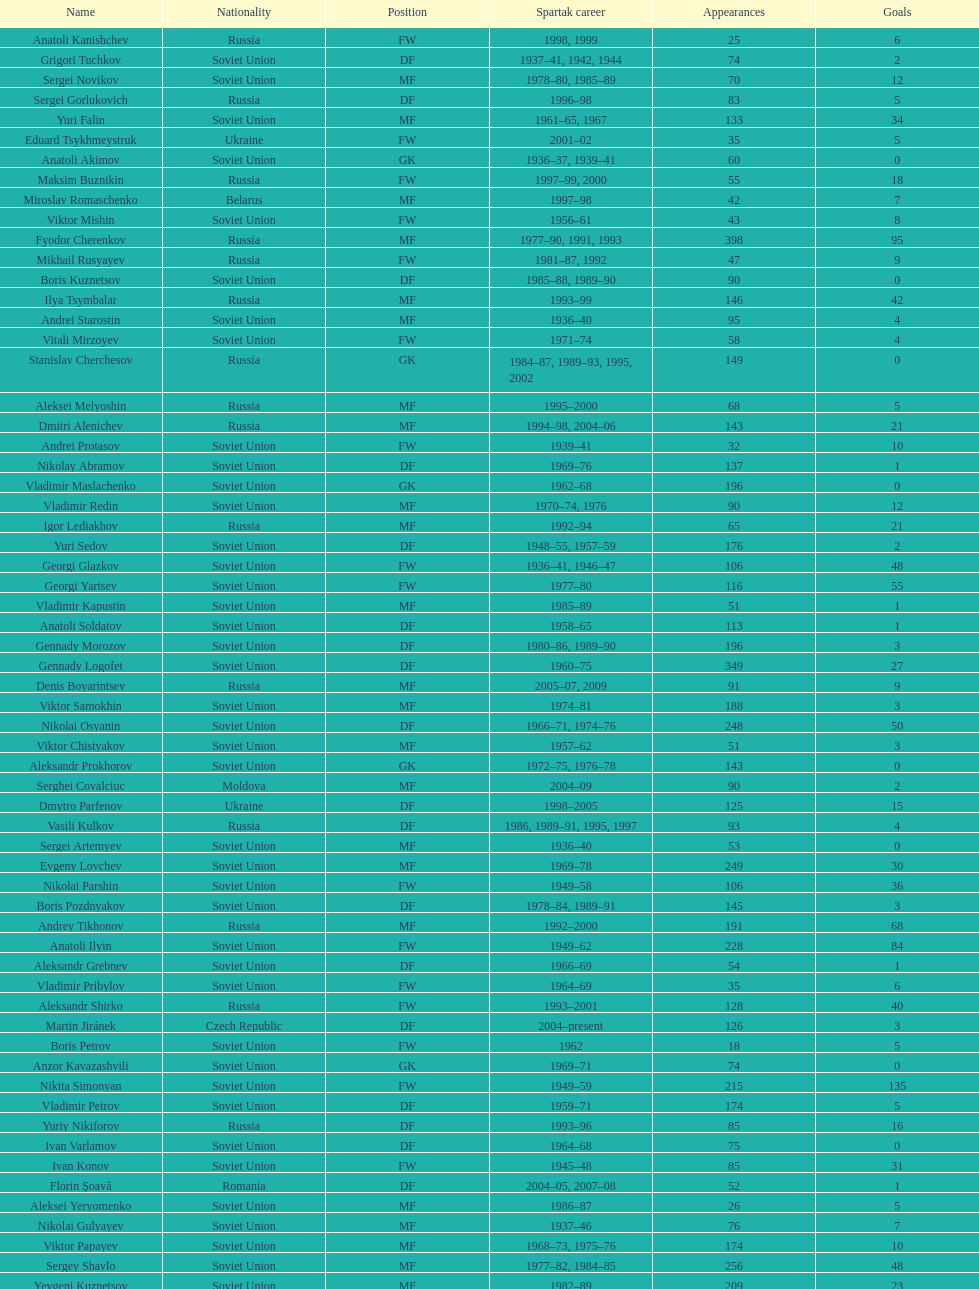Who had the highest number of appearances? Fyodor Cherenkov. 